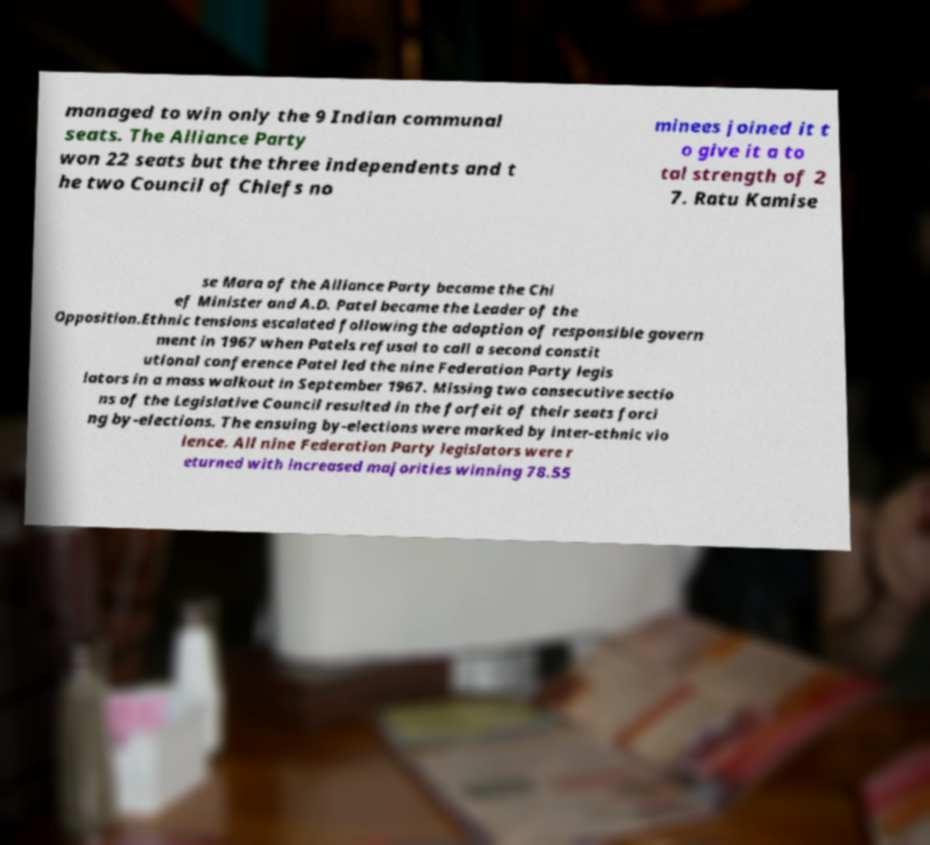Could you assist in decoding the text presented in this image and type it out clearly? managed to win only the 9 Indian communal seats. The Alliance Party won 22 seats but the three independents and t he two Council of Chiefs no minees joined it t o give it a to tal strength of 2 7. Ratu Kamise se Mara of the Alliance Party became the Chi ef Minister and A.D. Patel became the Leader of the Opposition.Ethnic tensions escalated following the adoption of responsible govern ment in 1967 when Patels refusal to call a second constit utional conference Patel led the nine Federation Party legis lators in a mass walkout in September 1967. Missing two consecutive sectio ns of the Legislative Council resulted in the forfeit of their seats forci ng by-elections. The ensuing by-elections were marked by inter-ethnic vio lence. All nine Federation Party legislators were r eturned with increased majorities winning 78.55 